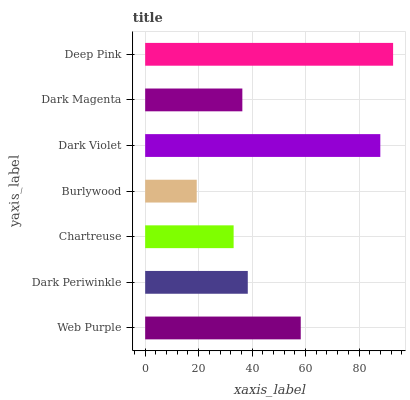Is Burlywood the minimum?
Answer yes or no. Yes. Is Deep Pink the maximum?
Answer yes or no. Yes. Is Dark Periwinkle the minimum?
Answer yes or no. No. Is Dark Periwinkle the maximum?
Answer yes or no. No. Is Web Purple greater than Dark Periwinkle?
Answer yes or no. Yes. Is Dark Periwinkle less than Web Purple?
Answer yes or no. Yes. Is Dark Periwinkle greater than Web Purple?
Answer yes or no. No. Is Web Purple less than Dark Periwinkle?
Answer yes or no. No. Is Dark Periwinkle the high median?
Answer yes or no. Yes. Is Dark Periwinkle the low median?
Answer yes or no. Yes. Is Deep Pink the high median?
Answer yes or no. No. Is Burlywood the low median?
Answer yes or no. No. 